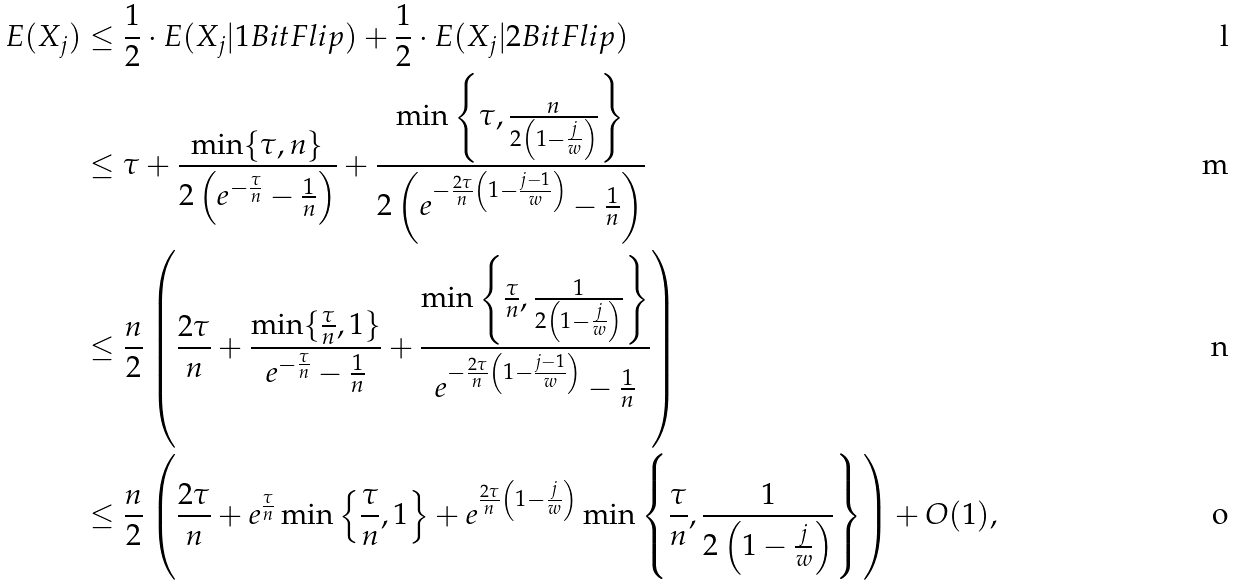<formula> <loc_0><loc_0><loc_500><loc_500>E ( X _ { j } ) & \leq \frac { 1 } { 2 } \cdot E ( X _ { j } | 1 B i t F l i p ) + \frac { 1 } { 2 } \cdot E ( X _ { j } | 2 B i t F l i p ) \\ & \leq \tau + \frac { \min \{ \tau , n \} } { 2 \left ( e ^ { - \frac { \tau } { n } } - \frac { 1 } { n } \right ) } + \frac { \min \left \{ \tau , \frac { n } { 2 \left ( 1 - \frac { j } { w } \right ) } \right \} } { 2 \left ( e ^ { - \frac { 2 \tau } { n } \left ( 1 - \frac { j - 1 } { w } \right ) } - \frac { 1 } { n } \right ) } \\ & \leq \frac { n } { 2 } \left ( \frac { 2 \tau } { n } + \frac { \min \{ \frac { \tau } { n } , 1 \} } { e ^ { - \frac { \tau } { n } } - \frac { 1 } { n } } + \frac { \min \left \{ \frac { \tau } { n } , \frac { 1 } { 2 \left ( 1 - \frac { j } { w } \right ) } \right \} } { e ^ { - \frac { 2 \tau } { n } \left ( 1 - \frac { j - 1 } { w } \right ) } - \frac { 1 } { n } } \right ) \\ & \leq \frac { n } { 2 } \left ( \frac { 2 \tau } { n } + e ^ { \frac { \tau } { n } } \min \left \{ \frac { \tau } { n } , 1 \right \} + e ^ { \frac { 2 \tau } { n } \left ( 1 - \frac { j } { w } \right ) } \min \left \{ \frac { \tau } { n } , \frac { 1 } { 2 \left ( 1 - \frac { j } { w } \right ) } \right \} \right ) + O ( 1 ) ,</formula> 